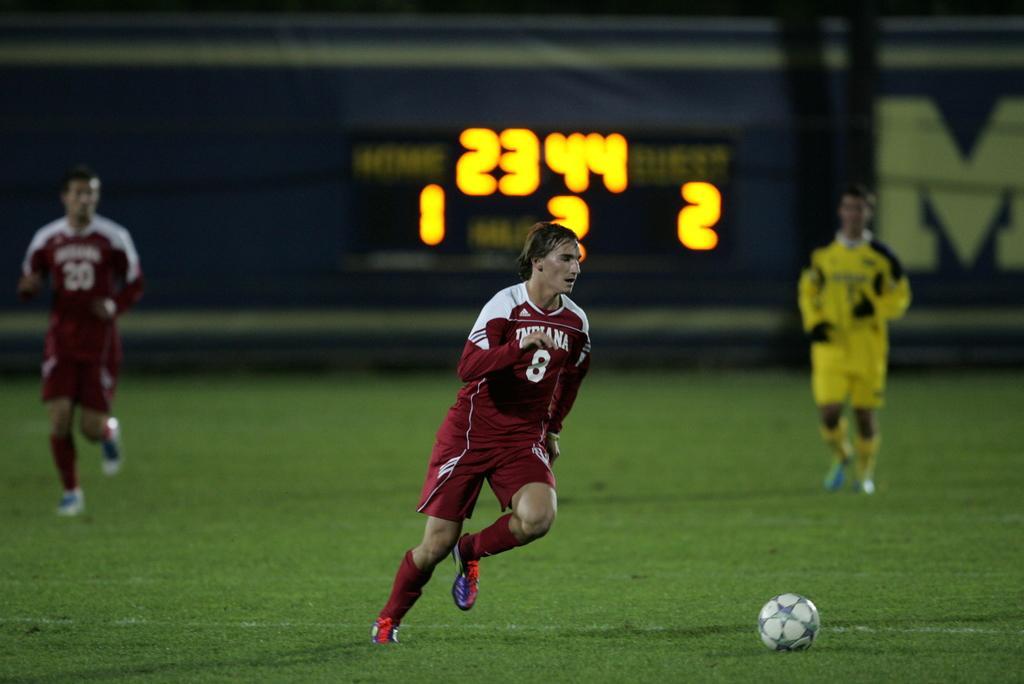In one or two sentences, can you explain what this image depicts? In the center of the image we can see three people playing football. At the bottom there is a ball. In the background there is a board. 